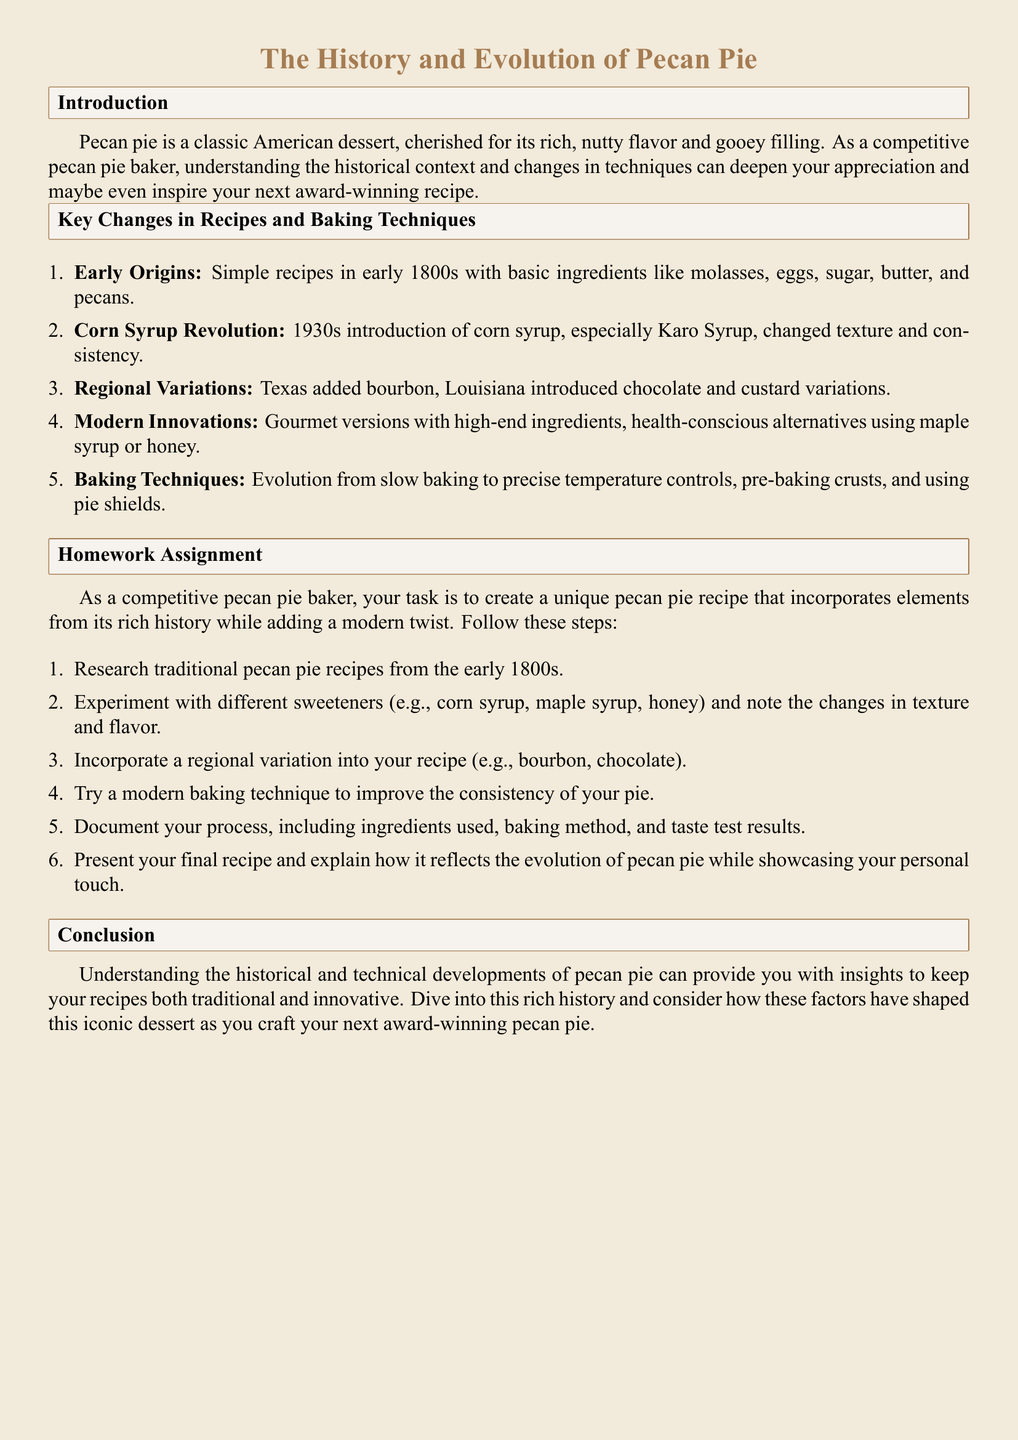What decade saw the introduction of corn syrup in pecan pie recipes? The document states that the corn syrup revolution occurred in the 1930s.
Answer: 1930s What is the primary change in the texture and consistency of pecan pie during the corn syrup revolution? The document notes that corn syrup changed the texture and consistency of pecan pie.
Answer: Texture and consistency What ingredient is commonly associated with Texas pecan pie variations? According to the document, Texas added bourbon to its pecan pie variations.
Answer: Bourbon How many steps are there in the Homework assignment section? The document lists six steps in the Homework assignment.
Answer: Six What is one modern baking technique mentioned in the document? The document mentions the use of precise temperature controls as a modern baking technique.
Answer: Precise temperature controls What was the characteristic of pecan pie recipes in the early 1800s? The document describes early pecan pie recipes as having simple ingredients like molasses, eggs, sugar, butter, and pecans.
Answer: Simple ingredients Which sweetener options should you experiment with according to the Homework assignment? The document suggests experimenting with corn syrup, maple syrup, and honey as sweetener options.
Answer: Corn syrup, maple syrup, honey What is the purpose of incorporating a regional variation in your recipe? The document implies that incorporating a regional variation enhances the uniqueness and creativity of your pecan pie.
Answer: To enhance uniqueness What does the conclusion emphasize about the historical context of pecan pie? The conclusion emphasizes that historical and technical developments shape the recipes of pecan pie.
Answer: They shape the recipes 